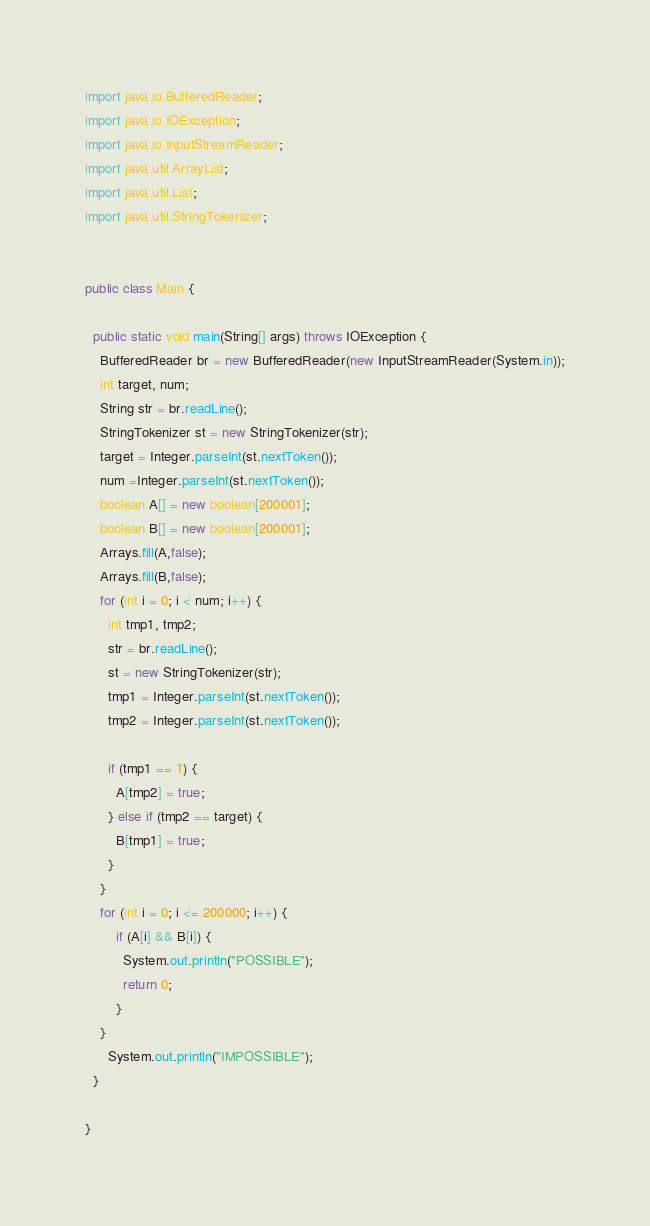Convert code to text. <code><loc_0><loc_0><loc_500><loc_500><_Java_>import java.io.BufferedReader;
import java.io.IOException;
import java.io.InputStreamReader;
import java.util.ArrayList;
import java.util.List;
import java.util.StringTokenizer;
 
 
public class Main {

  public static void main(String[] args) throws IOException {
    BufferedReader br = new BufferedReader(new InputStreamReader(System.in));
    int target, num;
    String str = br.readLine();
    StringTokenizer st = new StringTokenizer(str);
    target = Integer.parseInt(st.nextToken());
    num =Integer.parseInt(st.nextToken());
    boolean A[] = new boolean[200001];
    boolean B[] = new boolean[200001];
    Arrays.fill(A,false);
    Arrays.fill(B,false);
    for (int i = 0; i < num; i++) {
      int tmp1, tmp2;
      str = br.readLine();
      st = new StringTokenizer(str);
      tmp1 = Integer.parseInt(st.nextToken());
      tmp2 = Integer.parseInt(st.nextToken());
      
      if (tmp1 == 1) {
        A[tmp2] = true;
      } else if (tmp2 == target) {
        B[tmp1] = true;
      }
    }
    for (int i = 0; i <= 200000; i++) {
        if (A[i] && B[i]) {
          System.out.println("POSSIBLE");
          return 0;
        }
    }
      System.out.println("IMPOSSIBLE");
  }
 
}</code> 